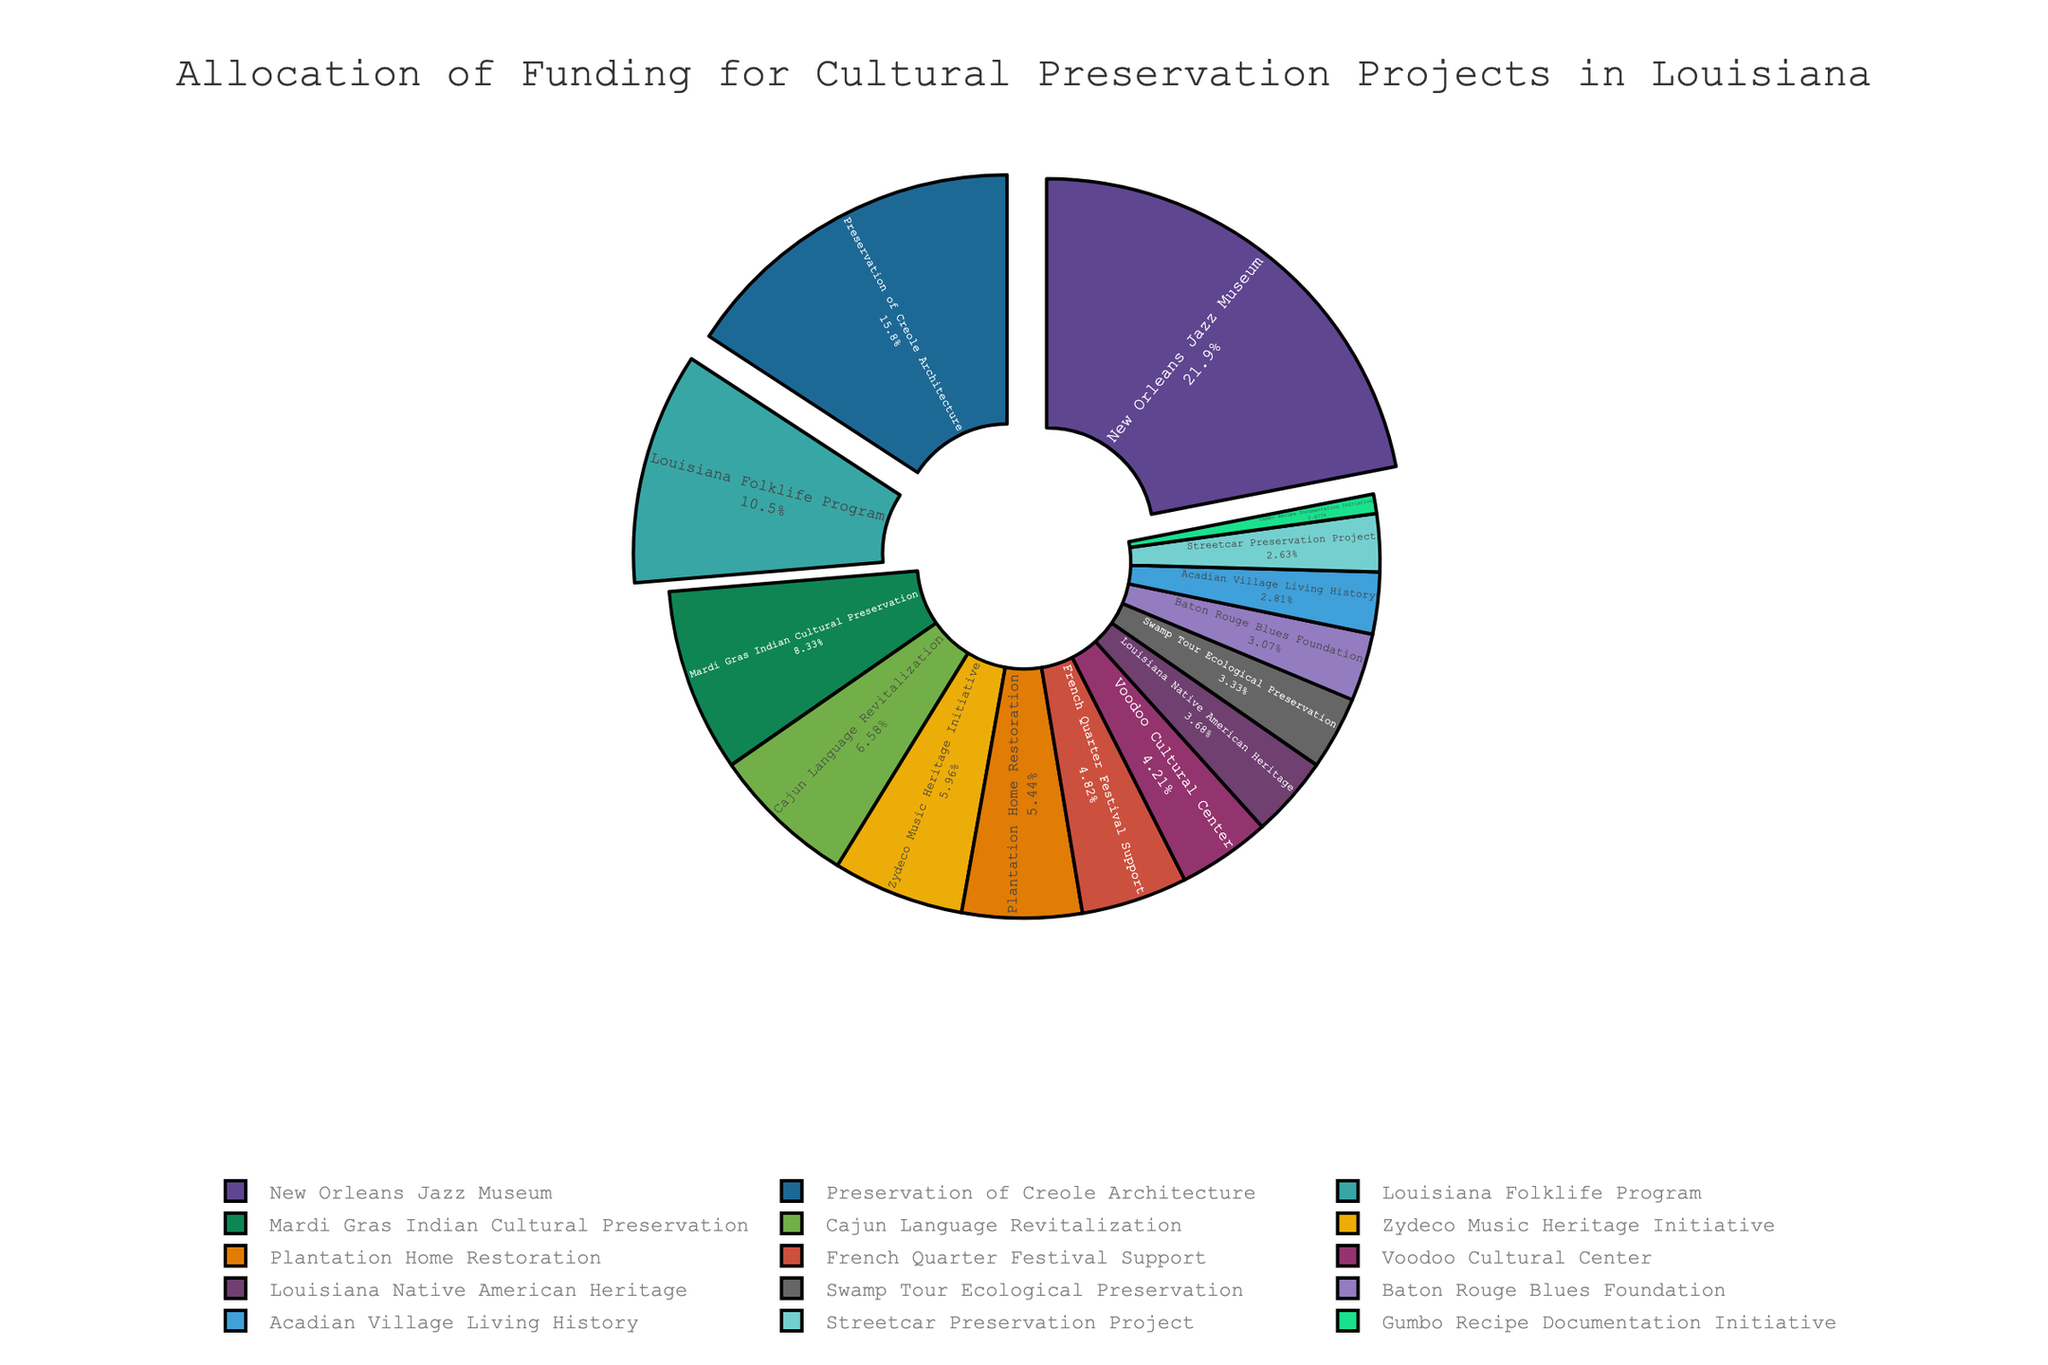What is the percentage of the total funding that the New Orleans Jazz Museum receives? The New Orleans Jazz Museum receives $2,500,000 in funding. To find the percentage, divide the funding amount by the total funding and multiply by 100. Sum up all funding allocations ($2,500,000 + $1,800,000 + ... + $100,000) which equals $10,300,000. Then, \( \frac{2,500,000}{10,300,000} \times 100 \approx 24.27\% \)
Answer: 24.27% How does the funding for the Preservation of Creole Architecture compare to the Zydeco Music Heritage Initiative? The Preservation of Creole Architecture receives $1,800,000 and the Zydeco Music Heritage Initiative receives $680,000. Comparing both, $1,800,000 is greater than $680,000 by $1,120,000.
Answer: $1,120,000 Which project has the lowest funding allocation and how much is it? By examining the pie chart, the Gumbo Recipe Documentation Initiative has the smallest slice, representing the lowest allocation. It receives $100,000.
Answer: $100,000 What is the combined funding percentage for the Louisiana Folklife Program and Mardi Gras Indian Cultural Preservation? The Louisiana Folklife Program receives $1,200,000 and Mardi Gras Indian Cultural Preservation receives $950,000. The total combined funding is $2,150,000. Divide this by the total funding of $10,300,000 and multiply by 100 to find the percentage: \( \frac{2,150,000}{10,300,000} \times 100 \approx 20.87\% \)
Answer: 20.87% How many projects have a funding allocation greater than or equal to $1,000,000? From the figure, we observe the funding allocations. Projects with allocations greater than or equal to $1,000,000 are: New Orleans Jazz Museum, Preservation of Creole Architecture, and Louisiana Folklife Program, totaling 3 projects.
Answer: 3 What visualization does the chart use to emphasize the top three funded projects? The pie chart visually emphasizes the top three funded projects by slightly pulling out these slices from the center, making them stand out.
Answer: pulling out slices What fraction of the total funding is allocated to the Cajun Language Revitalization and Baton Rouge Blues Foundation combined? Cajun Language Revitalization receives $750,000 and Baton Rouge Blues Foundation receives $350,000. Combined, they receive $1,100,000. The fraction is calculated as \(\frac{1,100,000}{10,300,000}\), which reduces to approximately \(\frac{11}{103}\).
Answer: \(\frac{11}{103}\) Which project has more funding: Streetcar Preservation Project or Swamp Tour Ecological Preservation, and by how much? The Streetcar Preservation Project has a funding allocation of $300,000, while the Swamp Tour Ecological Preservation has $380,000. The Swamp Tour Ecological Preservation has $80,000 more funding.
Answer: $80,000 What color represents the Voodoo Cultural Center's funding allocation in the pie chart? Observing the chart, the Voodoo Cultural Center is represented by a specific color. Although the exact color name can vary, typically it would be visually distinguishable from the legend.
Answer: (Color from Legend) What is the average funding allocation for the given cultural preservation projects? Sum up all the funding allocations which equal $10,300,000. There are 15 projects. Thus, the average funding allocation is \( \frac{10,300,000}{15} \approx 686,667\).
Answer: $686,667 